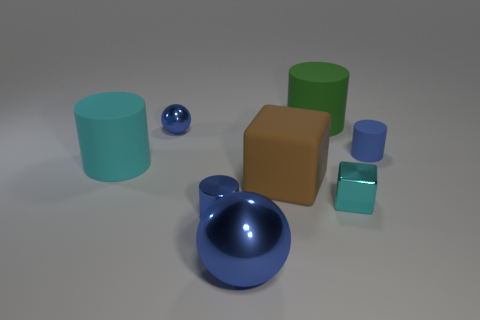There is a blue object that is to the left of the green matte cylinder and behind the large cyan cylinder; what is its size?
Offer a terse response. Small. The matte thing that is the same color as the small metal block is what size?
Provide a succinct answer. Large. Is there a tiny metal cylinder that has the same color as the big metal sphere?
Your answer should be compact. Yes. Do the tiny metal ball and the big shiny thing have the same color?
Give a very brief answer. Yes. There is a tiny blue metallic thing that is in front of the large brown matte thing; is its shape the same as the small blue matte thing?
Ensure brevity in your answer.  Yes. What number of other green metallic cylinders are the same size as the green cylinder?
Make the answer very short. 0. The large matte object that is the same color as the tiny cube is what shape?
Provide a short and direct response. Cylinder. There is a large object behind the tiny metal sphere; is there a large rubber cylinder that is to the left of it?
Ensure brevity in your answer.  Yes. What number of things are blue metal things in front of the big block or small blue rubber spheres?
Offer a terse response. 2. What number of large red matte blocks are there?
Offer a very short reply. 0. 